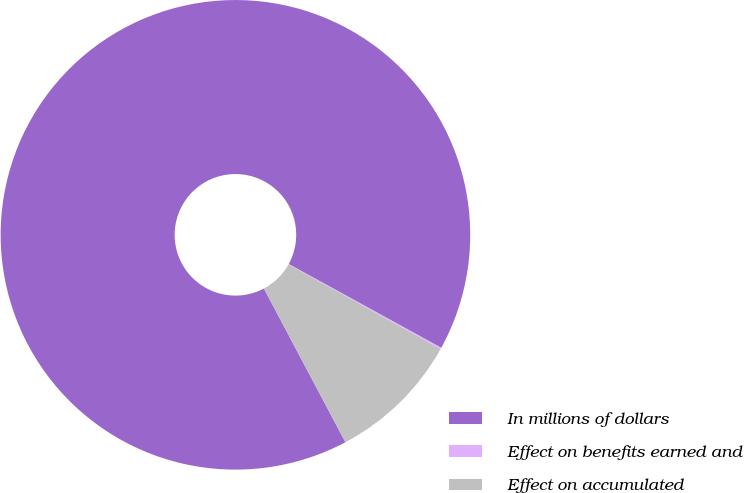Convert chart to OTSL. <chart><loc_0><loc_0><loc_500><loc_500><pie_chart><fcel>In millions of dollars<fcel>Effect on benefits earned and<fcel>Effect on accumulated<nl><fcel>90.75%<fcel>0.09%<fcel>9.16%<nl></chart> 